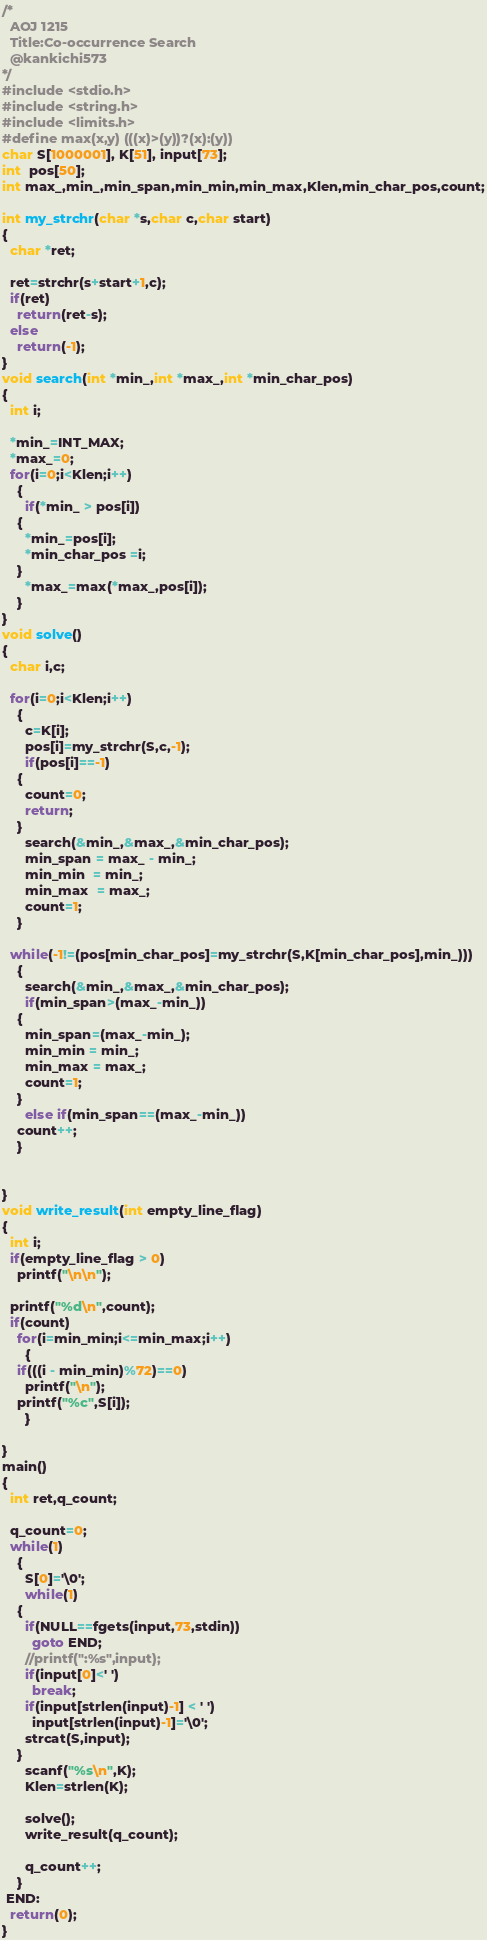Convert code to text. <code><loc_0><loc_0><loc_500><loc_500><_C_>/*
  AOJ 1215
  Title:Co-occurrence Search
  @kankichi573
*/
#include <stdio.h>
#include <string.h>
#include <limits.h>
#define max(x,y) (((x)>(y))?(x):(y))
char S[1000001], K[51], input[73];
int  pos[50];
int max_,min_,min_span,min_min,min_max,Klen,min_char_pos,count;

int my_strchr(char *s,char c,char start)
{
  char *ret;

  ret=strchr(s+start+1,c);
  if(ret)
    return(ret-s);
  else
    return(-1);
}
void search(int *min_,int *max_,int *min_char_pos)
{
  int i;

  *min_=INT_MAX;
  *max_=0;
  for(i=0;i<Klen;i++)
    {
      if(*min_ > pos[i])
	{
	  *min_=pos[i];
	  *min_char_pos =i;
	}
      *max_=max(*max_,pos[i]);
    }
}
void solve()
{
  char i,c;

  for(i=0;i<Klen;i++)
    {
      c=K[i];
      pos[i]=my_strchr(S,c,-1);
      if(pos[i]==-1)
	{
	  count=0;
	  return;
	}
      search(&min_,&max_,&min_char_pos);
      min_span = max_ - min_;
      min_min  = min_;
      min_max  = max_;
      count=1;
    }
  
  while(-1!=(pos[min_char_pos]=my_strchr(S,K[min_char_pos],min_)))
    {
      search(&min_,&max_,&min_char_pos);
      if(min_span>(max_-min_))
	{
	  min_span=(max_-min_);
	  min_min = min_;
	  min_max = max_;
	  count=1;
	}
      else if(min_span==(max_-min_))
	count++;
    }
  

}
void write_result(int empty_line_flag)
{
  int i;
  if(empty_line_flag > 0)
    printf("\n\n");

  printf("%d\n",count);
  if(count)
    for(i=min_min;i<=min_max;i++)
      {
	if(((i - min_min)%72)==0)
	  printf("\n");
	printf("%c",S[i]);
      }

}
main()
{
  int ret,q_count;

  q_count=0;
  while(1)
    {
      S[0]='\0';
      while(1)
	{
	  if(NULL==fgets(input,73,stdin))
	    goto END;
	  //printf(":%s",input);
	  if(input[0]<' ')
	    break;
	  if(input[strlen(input)-1] < ' ')
	    input[strlen(input)-1]='\0';
	  strcat(S,input);
	}
      scanf("%s\n",K);
      Klen=strlen(K);
      
      solve();
      write_result(q_count);
      
      q_count++;
    }
 END:
  return(0);
}</code> 